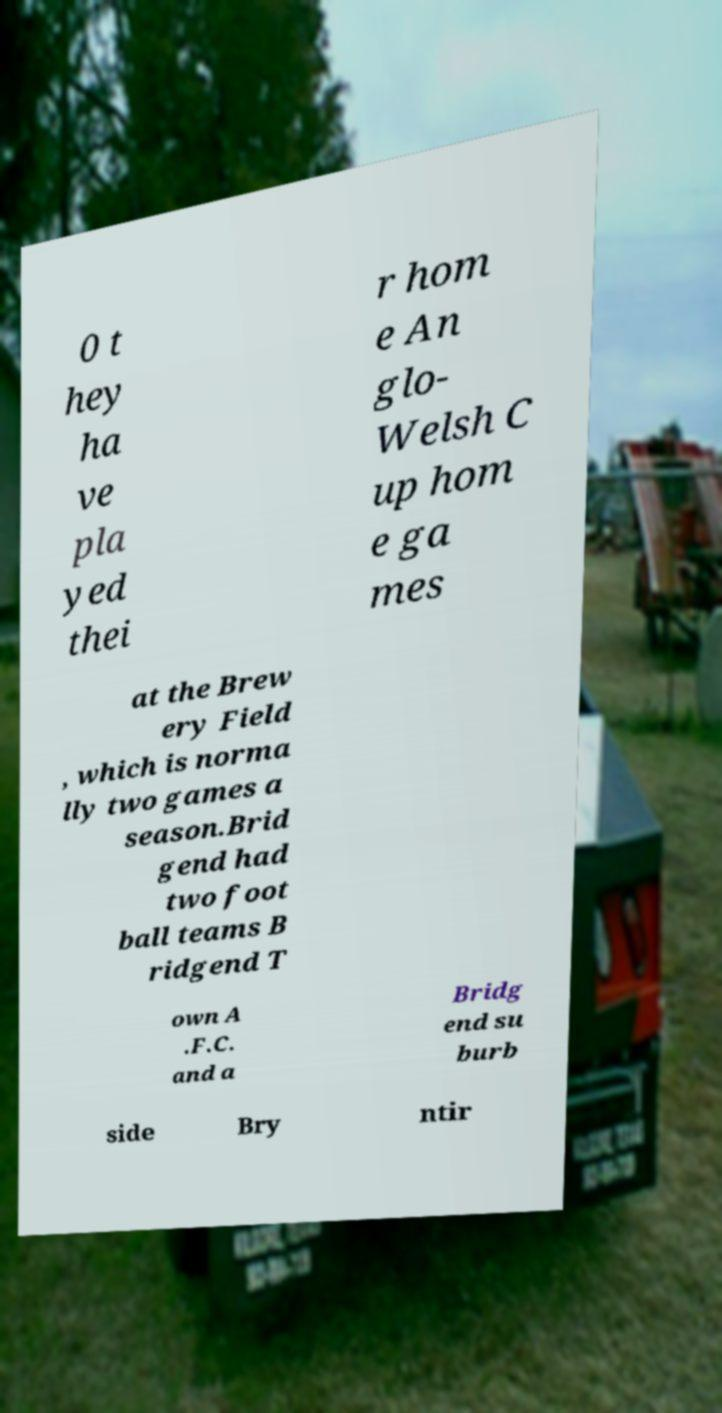Please identify and transcribe the text found in this image. 0 t hey ha ve pla yed thei r hom e An glo- Welsh C up hom e ga mes at the Brew ery Field , which is norma lly two games a season.Brid gend had two foot ball teams B ridgend T own A .F.C. and a Bridg end su burb side Bry ntir 